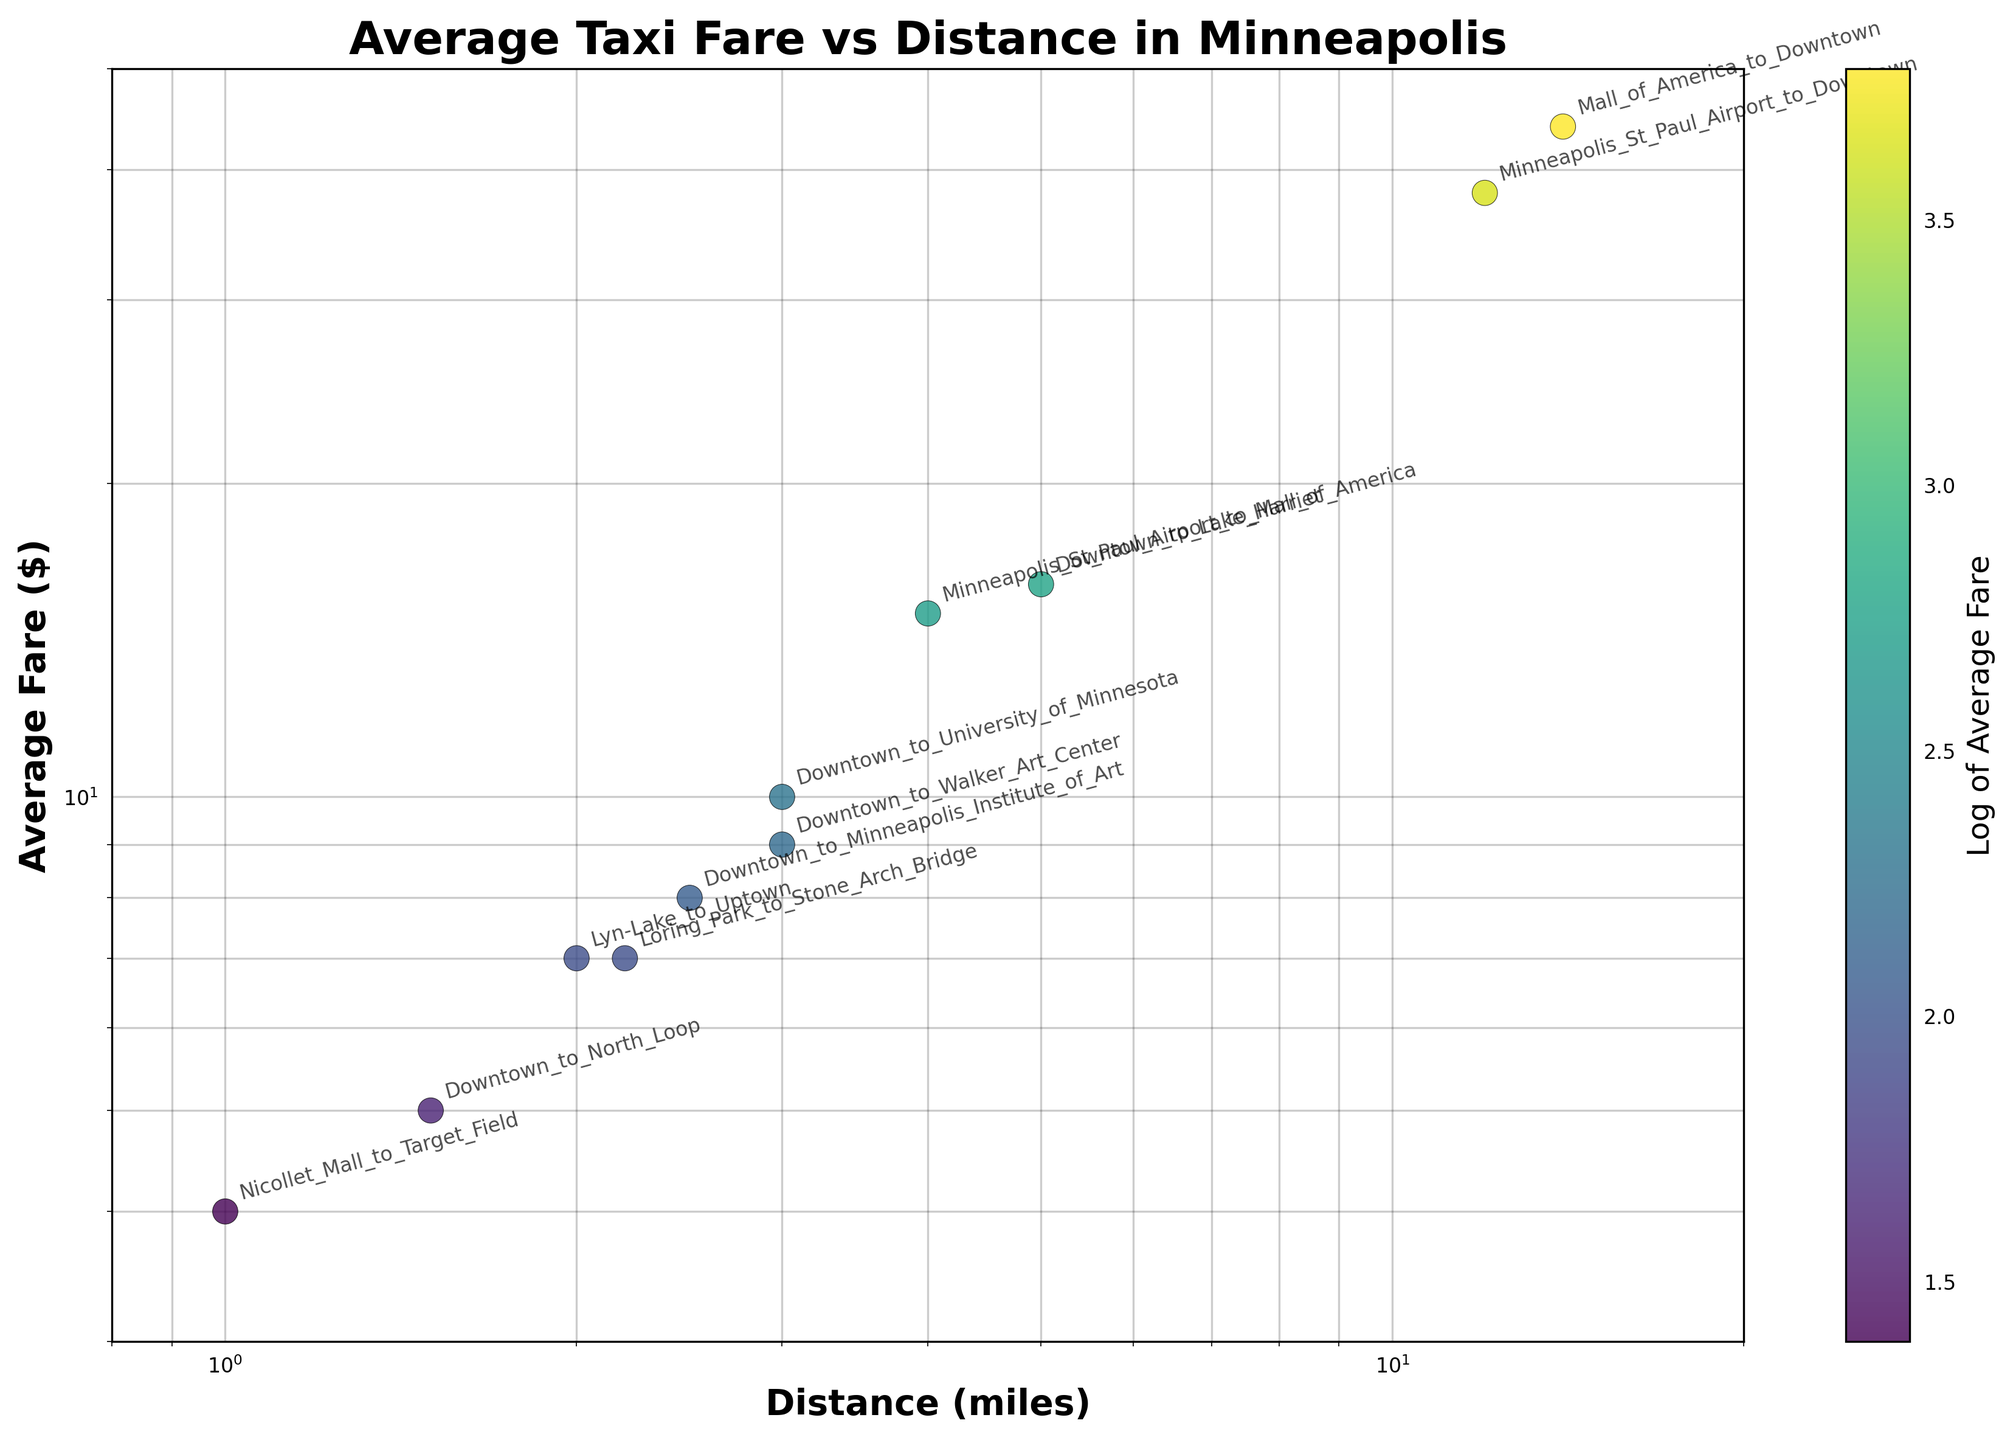What is the title of the plot? The title of the plot is located at the top center of the figure. It reads "Average Taxi Fare vs Distance in Minneapolis".
Answer: Average Taxi Fare vs Distance in Minneapolis How many data points are shown in the scatter plot? Each data point represents a different route, and there are 11 routes listed in the data provided. Hence, there are 11 data points in the scatter plot.
Answer: 11 Which route has the highest average fare? By examining the scatter plot, the point located farthest up on the y-axis indicates the highest fare. It corresponds to the route Mall_of_America_to_Downtown with an average fare of $44.
Answer: Mall_of_America_to_Downtown What is the range of distances shown in the scatter plot? The x-axis shows the distance in miles on a logarithmic scale. The minimum value is around 1 mile, and the maximum is around 20 miles.
Answer: 1 to 20 miles Which route has the shortest distance traveled? The route with the smallest x-axis value will have the shortest distance. This corresponds to the Nicollet_Mall_to_Target_Field route with a distance of 1 mile.
Answer: Nicollet_Mall_to_Target_Field Is there a general trend between distance and average fare? Observing the scatter plot, we see that as the distance in miles increases (x-axis), the average fare in dollars (y-axis) generally increases, indicating a positive correlation between distance traveled and average fare.
Answer: Yes, positive correlation Which two routes have the closest average fares despite having different distances? By examining points close to each other on the y-axis but different on the x-axis: Loring_Park_to_Stone_Arch_Bridge and Lyn-Lake_to_Uptown both have an average fare of $7 despite having different distances of 2.2 miles and 2 miles, respectively.
Answer: Loring_Park_to_Stone_Arch_Bridge and Lyn-Lake_to_Uptown How does the fare for the Downtown_to_North_Loop route compare to the average fare for routes of similar distance? The Downtown_to_North_Loop route has a distance of 1.5 miles and an average fare of $5. By observing other data points with similar distances (around 1.5 miles), it appears that Downtown_to_North_Loop has a slightly lower fare compared to similar routes like Nicollet_Mall_to_Target_Field (1 mile, $4).
Answer: Slightly lower What is the ratio of the highest fare to the lowest fare? The highest fare is $44, and the lowest is $4. The ratio is calculated as 44/4, which is 11.
Answer: 11 